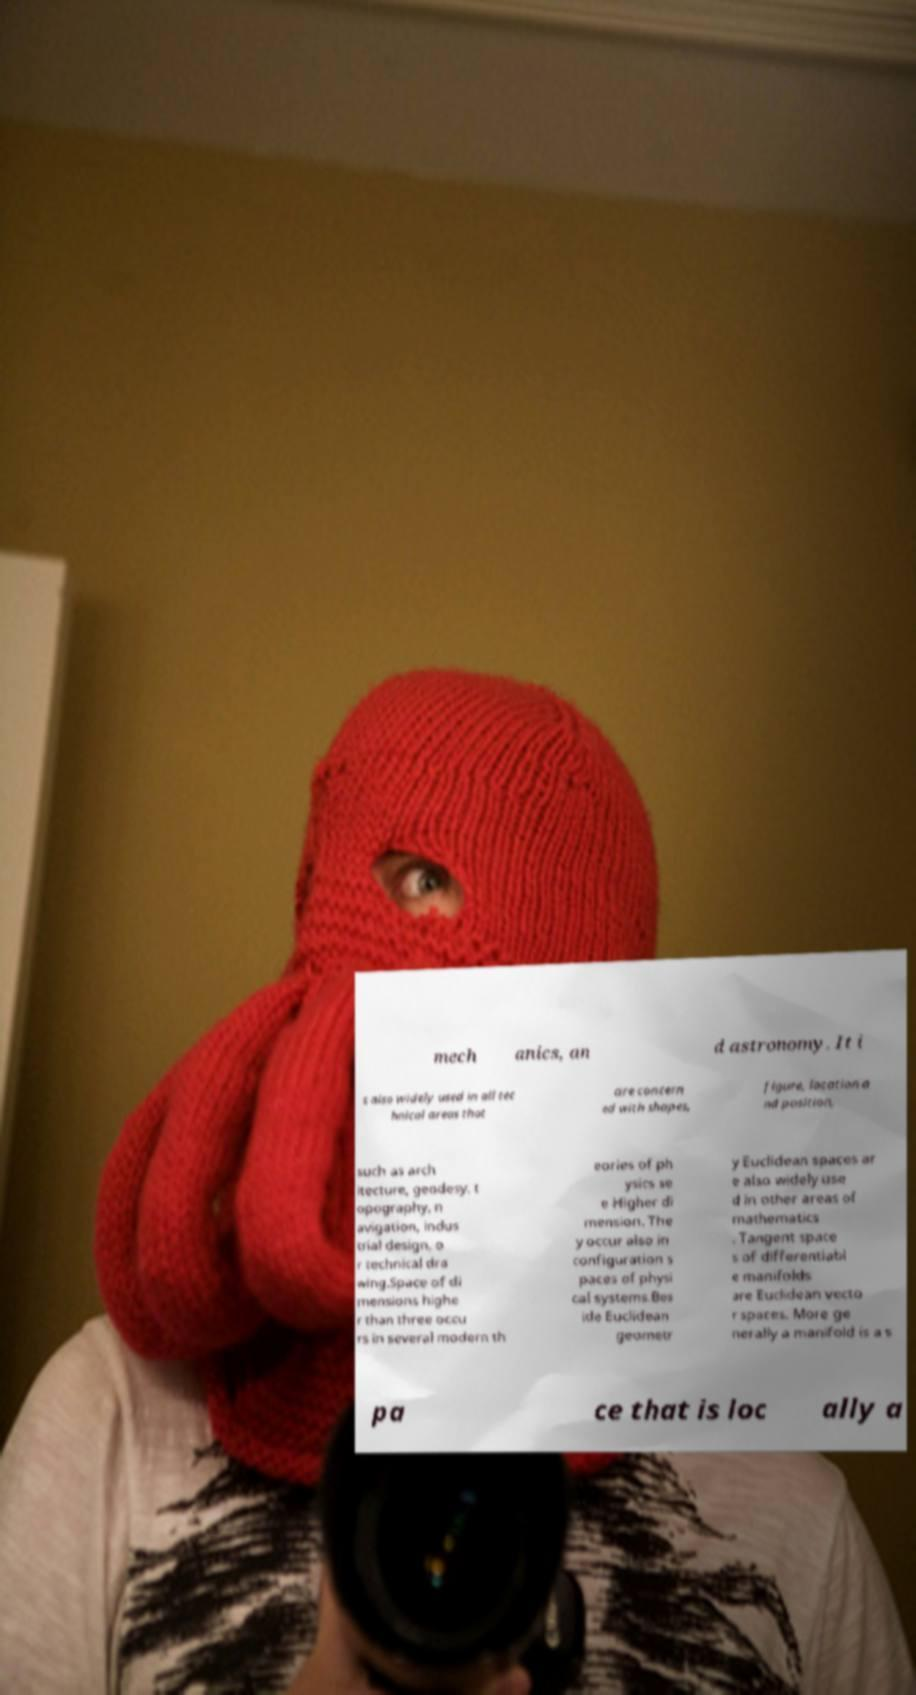What messages or text are displayed in this image? I need them in a readable, typed format. mech anics, an d astronomy. It i s also widely used in all tec hnical areas that are concern ed with shapes, figure, location a nd position, such as arch itecture, geodesy, t opography, n avigation, indus trial design, o r technical dra wing.Space of di mensions highe r than three occu rs in several modern th eories of ph ysics se e Higher di mension. The y occur also in configuration s paces of physi cal systems.Bes ide Euclidean geometr y Euclidean spaces ar e also widely use d in other areas of mathematics . Tangent space s of differentiabl e manifolds are Euclidean vecto r spaces. More ge nerally a manifold is a s pa ce that is loc ally a 